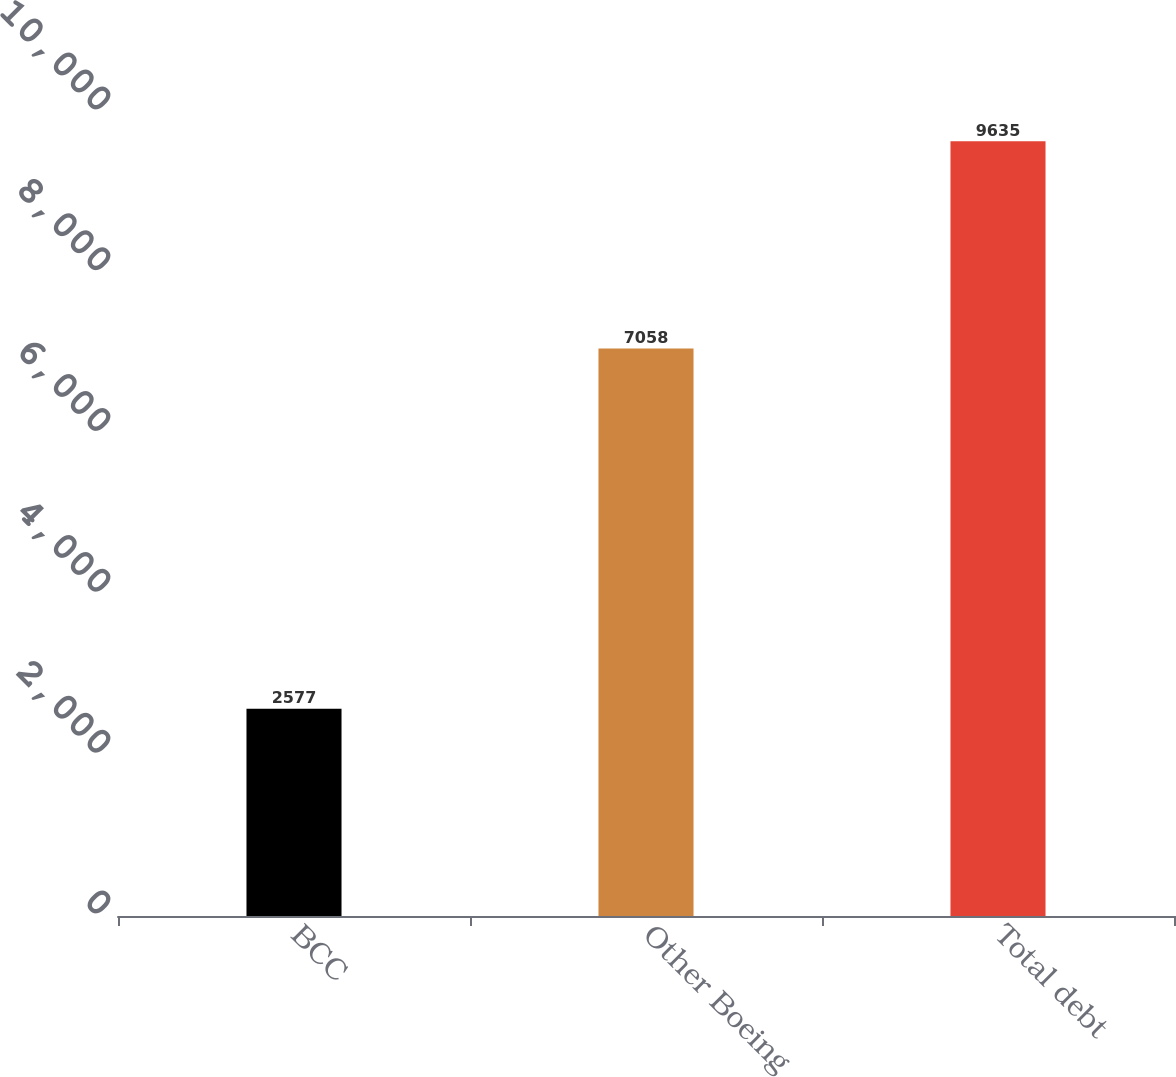Convert chart to OTSL. <chart><loc_0><loc_0><loc_500><loc_500><bar_chart><fcel>BCC<fcel>Other Boeing<fcel>Total debt<nl><fcel>2577<fcel>7058<fcel>9635<nl></chart> 